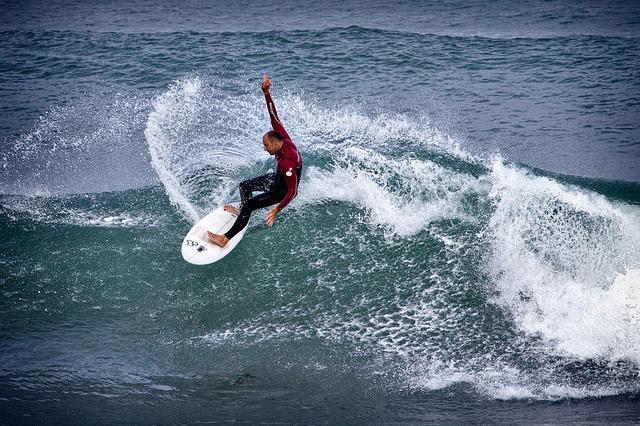How many adult giraffes are in the image?
Give a very brief answer. 0. 